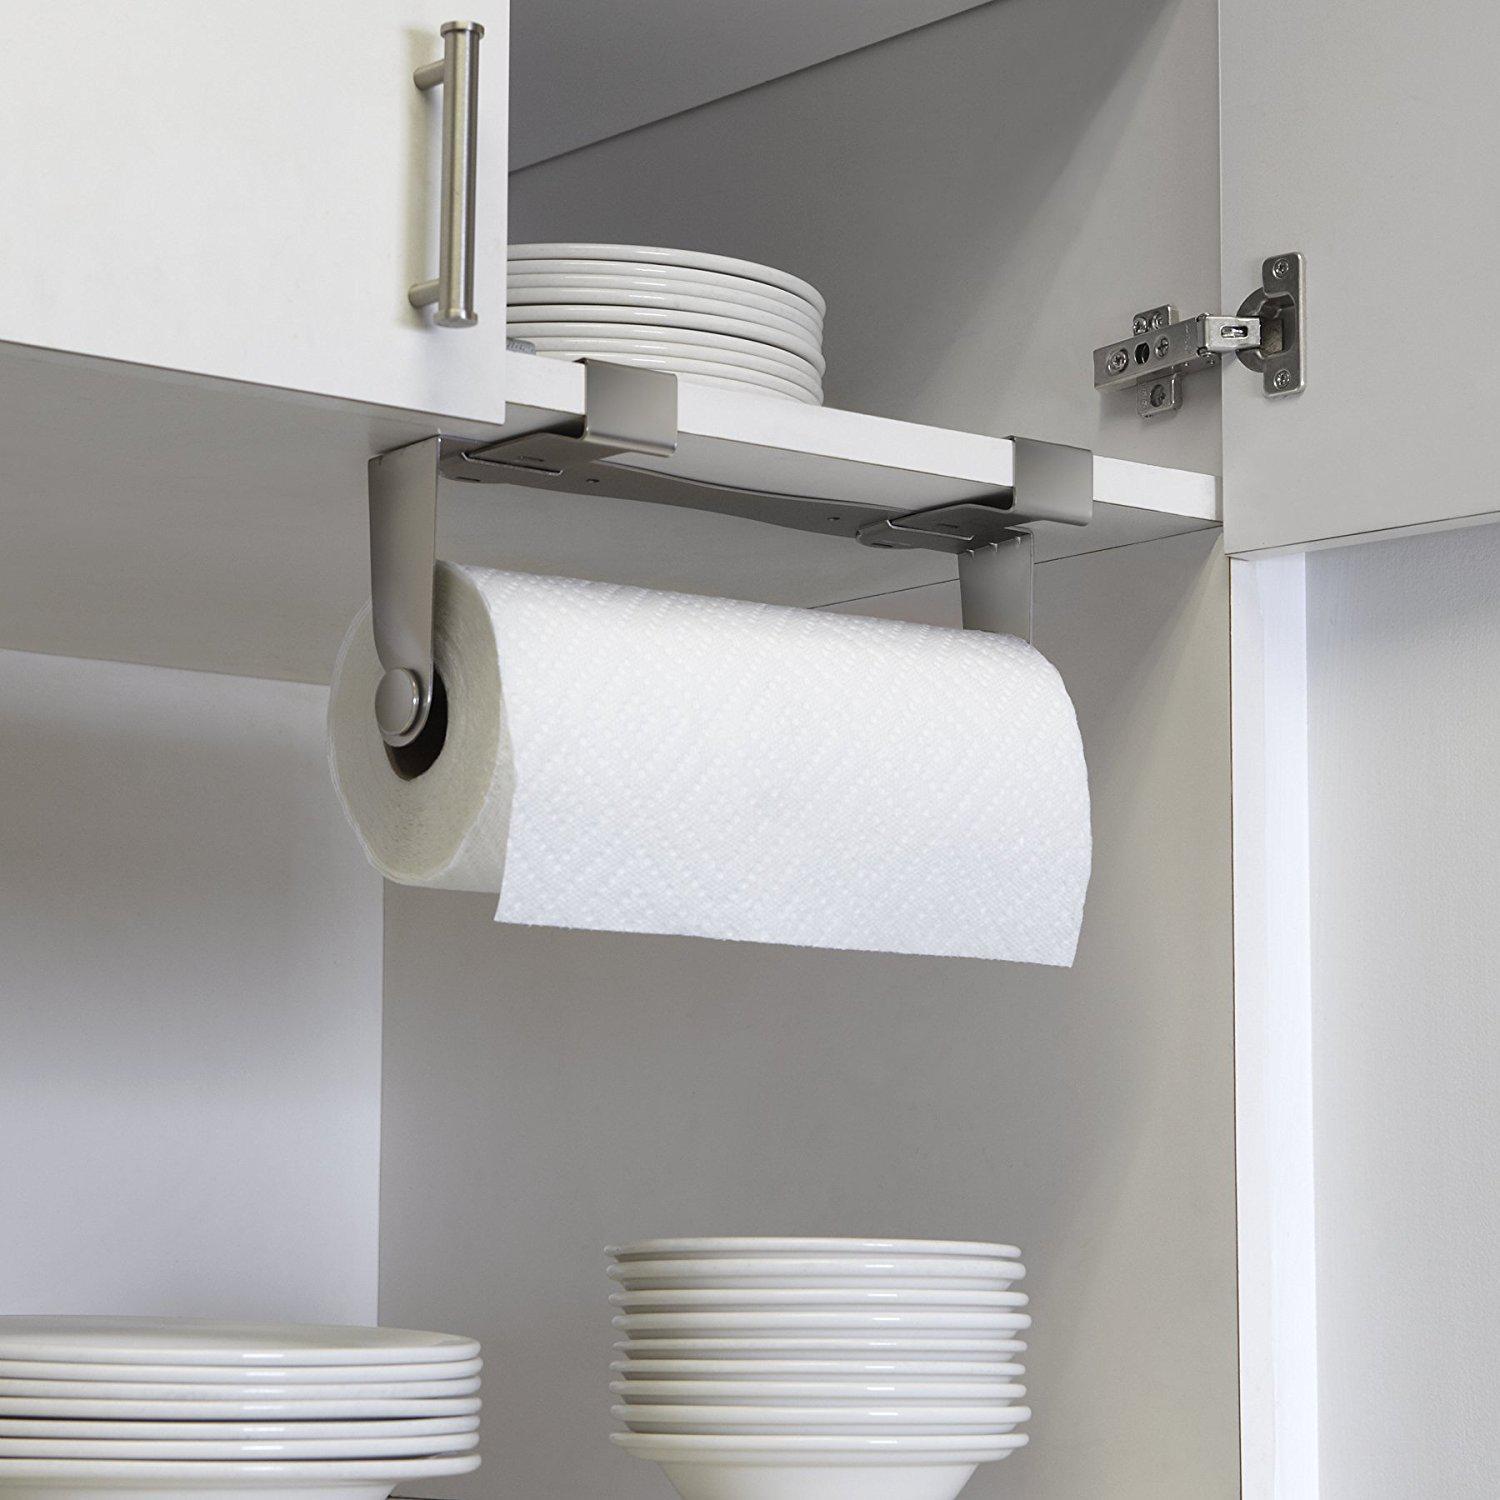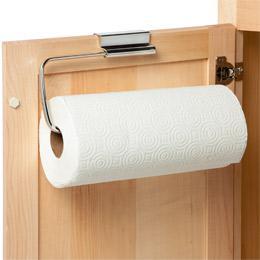The first image is the image on the left, the second image is the image on the right. Examine the images to the left and right. Is the description "The paper towels on the left are hanging under a cabinet." accurate? Answer yes or no. Yes. 